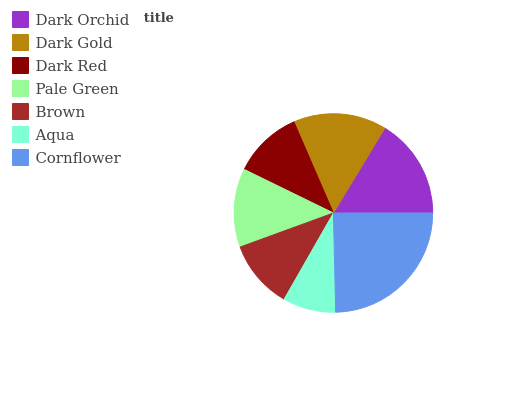Is Aqua the minimum?
Answer yes or no. Yes. Is Cornflower the maximum?
Answer yes or no. Yes. Is Dark Gold the minimum?
Answer yes or no. No. Is Dark Gold the maximum?
Answer yes or no. No. Is Dark Orchid greater than Dark Gold?
Answer yes or no. Yes. Is Dark Gold less than Dark Orchid?
Answer yes or no. Yes. Is Dark Gold greater than Dark Orchid?
Answer yes or no. No. Is Dark Orchid less than Dark Gold?
Answer yes or no. No. Is Pale Green the high median?
Answer yes or no. Yes. Is Pale Green the low median?
Answer yes or no. Yes. Is Cornflower the high median?
Answer yes or no. No. Is Aqua the low median?
Answer yes or no. No. 